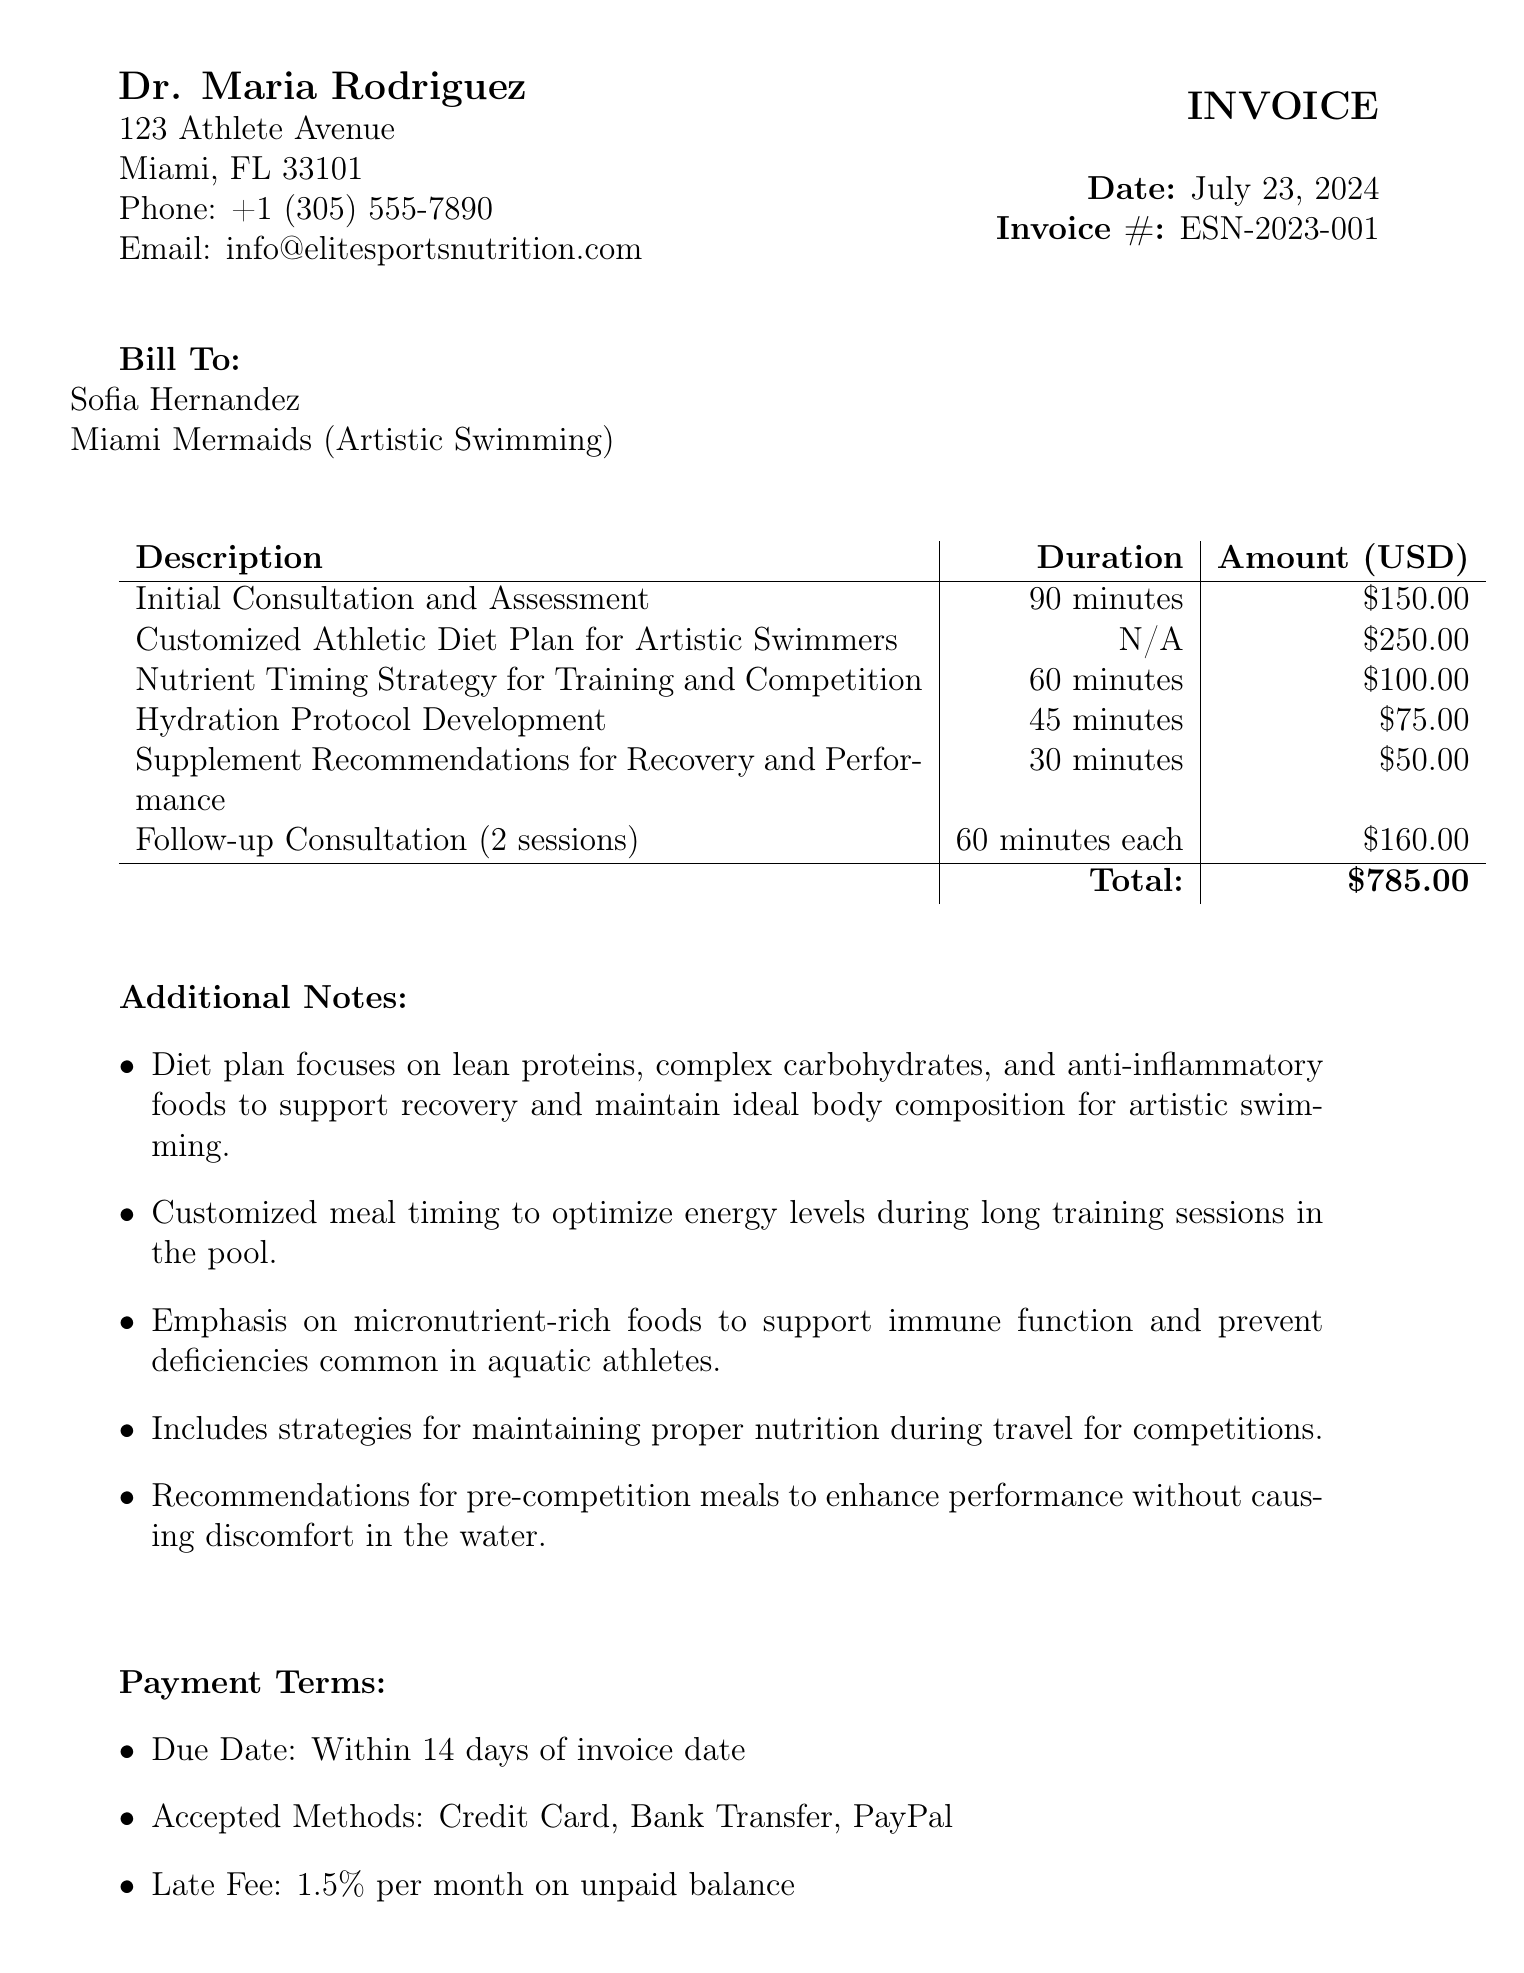What is the name of the nutritionist? The nutritionist's name is listed at the top of the invoice under the provider's details.
Answer: Dr. Maria Rodriguez What is the total amount due? The total amount is calculated from the sum of all service items on the invoice.
Answer: $785.00 How many minutes is the initial consultation? The duration of the initial consultation is specified in the service items section of the invoice.
Answer: 90 minutes What date is the invoice issued? The date of the invoice is indicated at the top right corner of the document, created using the current date.
Answer: Today's date How many follow-up consultation sessions are included? The number of follow-up consultation sessions is stated in the description of the corresponding service item.
Answer: 2 sessions What is the main focus of the diet plan? The focus is described in the additional notes section of the invoice, highlighting key dietary components.
Answer: Lean proteins, complex carbohydrates, and anti-inflammatory foods Which payment methods are accepted? The accepted payment methods are listed under the payment terms section, giving options for how to pay the invoice.
Answer: Credit Card, Bank Transfer, PayPal What is the late fee percentage? The late fee is stated in the payment terms section of the invoice, which specifies what percentage applies to unpaid balances.
Answer: 1.5% per month 